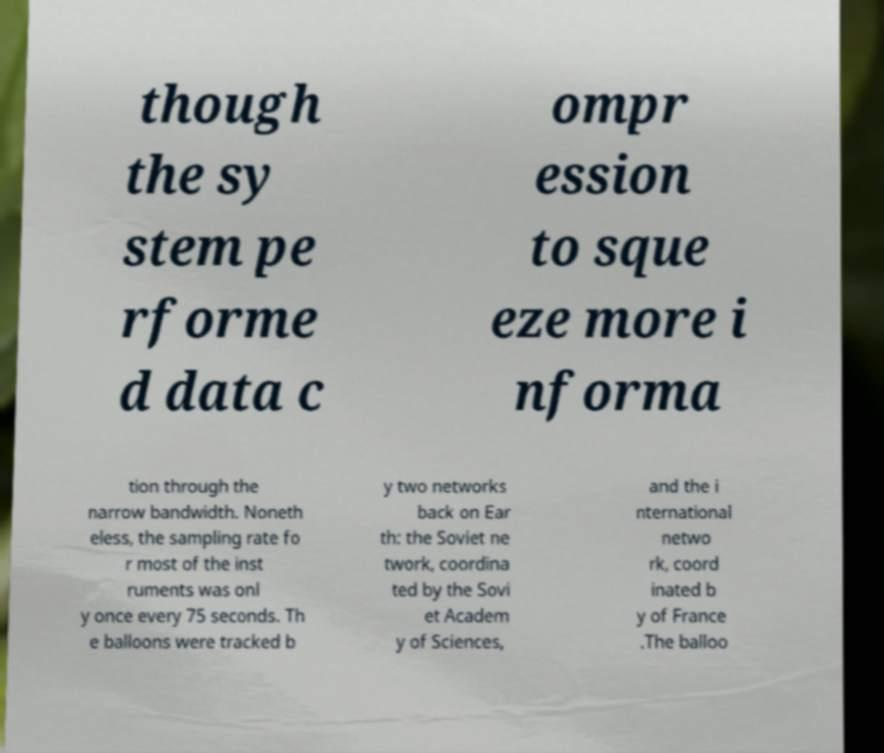I need the written content from this picture converted into text. Can you do that? though the sy stem pe rforme d data c ompr ession to sque eze more i nforma tion through the narrow bandwidth. Noneth eless, the sampling rate fo r most of the inst ruments was onl y once every 75 seconds. Th e balloons were tracked b y two networks back on Ear th: the Soviet ne twork, coordina ted by the Sovi et Academ y of Sciences, and the i nternational netwo rk, coord inated b y of France .The balloo 